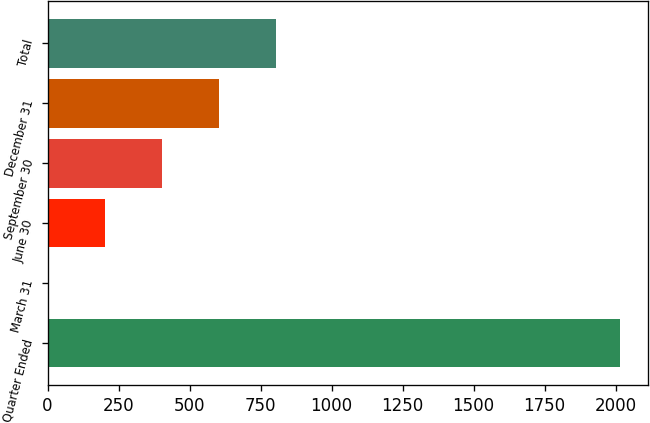<chart> <loc_0><loc_0><loc_500><loc_500><bar_chart><fcel>Quarter Ended<fcel>March 31<fcel>June 30<fcel>September 30<fcel>December 31<fcel>Total<nl><fcel>2014<fcel>0.34<fcel>201.71<fcel>403.08<fcel>604.45<fcel>805.82<nl></chart> 